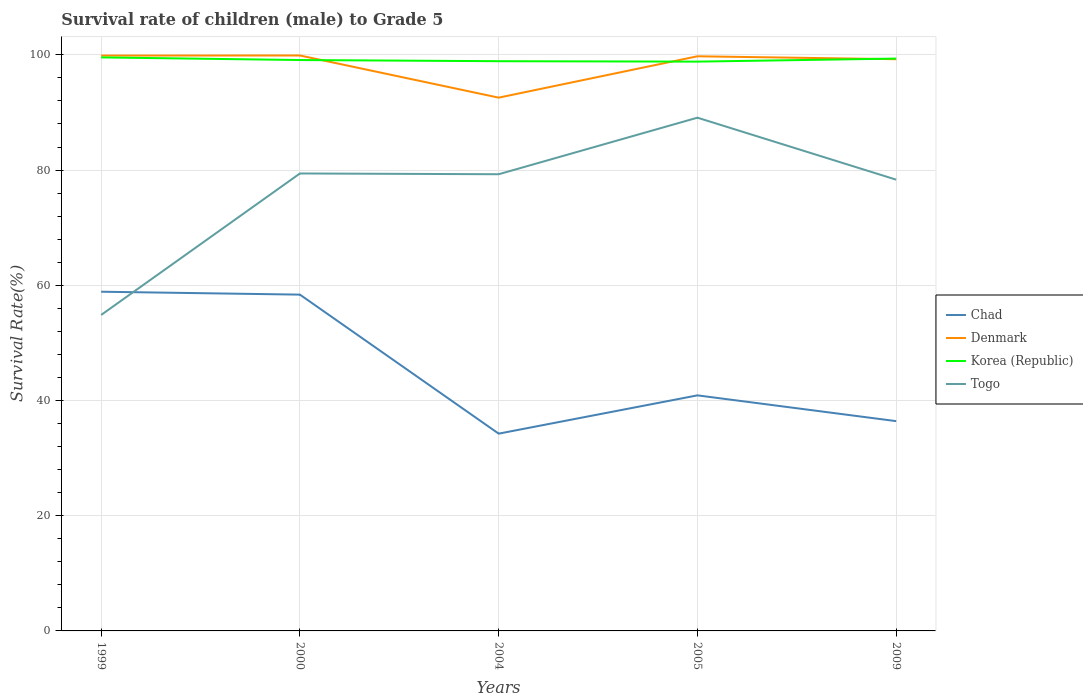Does the line corresponding to Chad intersect with the line corresponding to Korea (Republic)?
Ensure brevity in your answer.  No. Is the number of lines equal to the number of legend labels?
Provide a succinct answer. Yes. Across all years, what is the maximum survival rate of male children to grade 5 in Korea (Republic)?
Ensure brevity in your answer.  98.82. In which year was the survival rate of male children to grade 5 in Chad maximum?
Ensure brevity in your answer.  2004. What is the total survival rate of male children to grade 5 in Korea (Republic) in the graph?
Your answer should be very brief. -0.53. What is the difference between the highest and the second highest survival rate of male children to grade 5 in Togo?
Offer a very short reply. 34.24. How many lines are there?
Provide a succinct answer. 4. What is the difference between two consecutive major ticks on the Y-axis?
Keep it short and to the point. 20. Are the values on the major ticks of Y-axis written in scientific E-notation?
Provide a succinct answer. No. Does the graph contain grids?
Offer a terse response. Yes. Where does the legend appear in the graph?
Provide a succinct answer. Center right. How many legend labels are there?
Keep it short and to the point. 4. How are the legend labels stacked?
Your answer should be compact. Vertical. What is the title of the graph?
Offer a very short reply. Survival rate of children (male) to Grade 5. What is the label or title of the Y-axis?
Make the answer very short. Survival Rate(%). What is the Survival Rate(%) of Chad in 1999?
Offer a terse response. 58.88. What is the Survival Rate(%) in Denmark in 1999?
Ensure brevity in your answer.  99.88. What is the Survival Rate(%) of Korea (Republic) in 1999?
Provide a succinct answer. 99.56. What is the Survival Rate(%) of Togo in 1999?
Your answer should be compact. 54.85. What is the Survival Rate(%) in Chad in 2000?
Give a very brief answer. 58.38. What is the Survival Rate(%) in Denmark in 2000?
Your response must be concise. 99.89. What is the Survival Rate(%) of Korea (Republic) in 2000?
Your response must be concise. 99.1. What is the Survival Rate(%) in Togo in 2000?
Ensure brevity in your answer.  79.41. What is the Survival Rate(%) in Chad in 2004?
Provide a succinct answer. 34.25. What is the Survival Rate(%) of Denmark in 2004?
Ensure brevity in your answer.  92.57. What is the Survival Rate(%) in Korea (Republic) in 2004?
Your answer should be compact. 98.9. What is the Survival Rate(%) of Togo in 2004?
Provide a short and direct response. 79.28. What is the Survival Rate(%) in Chad in 2005?
Your answer should be compact. 40.89. What is the Survival Rate(%) in Denmark in 2005?
Ensure brevity in your answer.  99.75. What is the Survival Rate(%) in Korea (Republic) in 2005?
Ensure brevity in your answer.  98.82. What is the Survival Rate(%) in Togo in 2005?
Keep it short and to the point. 89.09. What is the Survival Rate(%) of Chad in 2009?
Ensure brevity in your answer.  36.42. What is the Survival Rate(%) in Denmark in 2009?
Give a very brief answer. 99.24. What is the Survival Rate(%) in Korea (Republic) in 2009?
Your answer should be very brief. 99.35. What is the Survival Rate(%) in Togo in 2009?
Make the answer very short. 78.33. Across all years, what is the maximum Survival Rate(%) of Chad?
Your answer should be very brief. 58.88. Across all years, what is the maximum Survival Rate(%) of Denmark?
Give a very brief answer. 99.89. Across all years, what is the maximum Survival Rate(%) in Korea (Republic)?
Offer a very short reply. 99.56. Across all years, what is the maximum Survival Rate(%) of Togo?
Ensure brevity in your answer.  89.09. Across all years, what is the minimum Survival Rate(%) of Chad?
Your response must be concise. 34.25. Across all years, what is the minimum Survival Rate(%) in Denmark?
Offer a very short reply. 92.57. Across all years, what is the minimum Survival Rate(%) of Korea (Republic)?
Give a very brief answer. 98.82. Across all years, what is the minimum Survival Rate(%) in Togo?
Your answer should be compact. 54.85. What is the total Survival Rate(%) in Chad in the graph?
Offer a terse response. 228.81. What is the total Survival Rate(%) in Denmark in the graph?
Your response must be concise. 491.33. What is the total Survival Rate(%) in Korea (Republic) in the graph?
Your response must be concise. 495.73. What is the total Survival Rate(%) in Togo in the graph?
Keep it short and to the point. 380.96. What is the difference between the Survival Rate(%) of Chad in 1999 and that in 2000?
Your response must be concise. 0.5. What is the difference between the Survival Rate(%) of Denmark in 1999 and that in 2000?
Ensure brevity in your answer.  -0.01. What is the difference between the Survival Rate(%) of Korea (Republic) in 1999 and that in 2000?
Make the answer very short. 0.46. What is the difference between the Survival Rate(%) of Togo in 1999 and that in 2000?
Your answer should be very brief. -24.56. What is the difference between the Survival Rate(%) in Chad in 1999 and that in 2004?
Make the answer very short. 24.63. What is the difference between the Survival Rate(%) in Denmark in 1999 and that in 2004?
Provide a short and direct response. 7.3. What is the difference between the Survival Rate(%) in Korea (Republic) in 1999 and that in 2004?
Offer a terse response. 0.66. What is the difference between the Survival Rate(%) in Togo in 1999 and that in 2004?
Ensure brevity in your answer.  -24.43. What is the difference between the Survival Rate(%) of Chad in 1999 and that in 2005?
Ensure brevity in your answer.  17.99. What is the difference between the Survival Rate(%) of Denmark in 1999 and that in 2005?
Give a very brief answer. 0.12. What is the difference between the Survival Rate(%) of Korea (Republic) in 1999 and that in 2005?
Provide a short and direct response. 0.73. What is the difference between the Survival Rate(%) of Togo in 1999 and that in 2005?
Offer a terse response. -34.24. What is the difference between the Survival Rate(%) in Chad in 1999 and that in 2009?
Keep it short and to the point. 22.46. What is the difference between the Survival Rate(%) of Denmark in 1999 and that in 2009?
Your answer should be very brief. 0.63. What is the difference between the Survival Rate(%) of Korea (Republic) in 1999 and that in 2009?
Offer a terse response. 0.21. What is the difference between the Survival Rate(%) of Togo in 1999 and that in 2009?
Your answer should be very brief. -23.48. What is the difference between the Survival Rate(%) in Chad in 2000 and that in 2004?
Your response must be concise. 24.13. What is the difference between the Survival Rate(%) in Denmark in 2000 and that in 2004?
Your answer should be compact. 7.32. What is the difference between the Survival Rate(%) in Korea (Republic) in 2000 and that in 2004?
Make the answer very short. 0.2. What is the difference between the Survival Rate(%) in Togo in 2000 and that in 2004?
Offer a very short reply. 0.13. What is the difference between the Survival Rate(%) of Chad in 2000 and that in 2005?
Provide a short and direct response. 17.49. What is the difference between the Survival Rate(%) of Denmark in 2000 and that in 2005?
Your answer should be compact. 0.14. What is the difference between the Survival Rate(%) in Korea (Republic) in 2000 and that in 2005?
Give a very brief answer. 0.28. What is the difference between the Survival Rate(%) in Togo in 2000 and that in 2005?
Give a very brief answer. -9.69. What is the difference between the Survival Rate(%) in Chad in 2000 and that in 2009?
Provide a succinct answer. 21.96. What is the difference between the Survival Rate(%) of Denmark in 2000 and that in 2009?
Ensure brevity in your answer.  0.65. What is the difference between the Survival Rate(%) in Korea (Republic) in 2000 and that in 2009?
Offer a very short reply. -0.25. What is the difference between the Survival Rate(%) of Togo in 2000 and that in 2009?
Make the answer very short. 1.07. What is the difference between the Survival Rate(%) in Chad in 2004 and that in 2005?
Provide a short and direct response. -6.65. What is the difference between the Survival Rate(%) in Denmark in 2004 and that in 2005?
Ensure brevity in your answer.  -7.18. What is the difference between the Survival Rate(%) in Korea (Republic) in 2004 and that in 2005?
Provide a short and direct response. 0.07. What is the difference between the Survival Rate(%) of Togo in 2004 and that in 2005?
Make the answer very short. -9.82. What is the difference between the Survival Rate(%) in Chad in 2004 and that in 2009?
Offer a terse response. -2.17. What is the difference between the Survival Rate(%) of Denmark in 2004 and that in 2009?
Offer a terse response. -6.67. What is the difference between the Survival Rate(%) in Korea (Republic) in 2004 and that in 2009?
Keep it short and to the point. -0.45. What is the difference between the Survival Rate(%) of Togo in 2004 and that in 2009?
Offer a terse response. 0.94. What is the difference between the Survival Rate(%) in Chad in 2005 and that in 2009?
Keep it short and to the point. 4.47. What is the difference between the Survival Rate(%) in Denmark in 2005 and that in 2009?
Make the answer very short. 0.51. What is the difference between the Survival Rate(%) of Korea (Republic) in 2005 and that in 2009?
Your response must be concise. -0.53. What is the difference between the Survival Rate(%) of Togo in 2005 and that in 2009?
Make the answer very short. 10.76. What is the difference between the Survival Rate(%) in Chad in 1999 and the Survival Rate(%) in Denmark in 2000?
Keep it short and to the point. -41.01. What is the difference between the Survival Rate(%) of Chad in 1999 and the Survival Rate(%) of Korea (Republic) in 2000?
Your answer should be very brief. -40.22. What is the difference between the Survival Rate(%) in Chad in 1999 and the Survival Rate(%) in Togo in 2000?
Your answer should be very brief. -20.53. What is the difference between the Survival Rate(%) in Denmark in 1999 and the Survival Rate(%) in Korea (Republic) in 2000?
Your answer should be very brief. 0.78. What is the difference between the Survival Rate(%) of Denmark in 1999 and the Survival Rate(%) of Togo in 2000?
Your response must be concise. 20.47. What is the difference between the Survival Rate(%) in Korea (Republic) in 1999 and the Survival Rate(%) in Togo in 2000?
Your response must be concise. 20.15. What is the difference between the Survival Rate(%) in Chad in 1999 and the Survival Rate(%) in Denmark in 2004?
Offer a very short reply. -33.69. What is the difference between the Survival Rate(%) in Chad in 1999 and the Survival Rate(%) in Korea (Republic) in 2004?
Offer a very short reply. -40.02. What is the difference between the Survival Rate(%) in Chad in 1999 and the Survival Rate(%) in Togo in 2004?
Make the answer very short. -20.39. What is the difference between the Survival Rate(%) of Denmark in 1999 and the Survival Rate(%) of Korea (Republic) in 2004?
Provide a succinct answer. 0.98. What is the difference between the Survival Rate(%) in Denmark in 1999 and the Survival Rate(%) in Togo in 2004?
Offer a very short reply. 20.6. What is the difference between the Survival Rate(%) of Korea (Republic) in 1999 and the Survival Rate(%) of Togo in 2004?
Your answer should be compact. 20.28. What is the difference between the Survival Rate(%) of Chad in 1999 and the Survival Rate(%) of Denmark in 2005?
Make the answer very short. -40.87. What is the difference between the Survival Rate(%) in Chad in 1999 and the Survival Rate(%) in Korea (Republic) in 2005?
Ensure brevity in your answer.  -39.94. What is the difference between the Survival Rate(%) in Chad in 1999 and the Survival Rate(%) in Togo in 2005?
Make the answer very short. -30.21. What is the difference between the Survival Rate(%) of Denmark in 1999 and the Survival Rate(%) of Korea (Republic) in 2005?
Your answer should be very brief. 1.05. What is the difference between the Survival Rate(%) of Denmark in 1999 and the Survival Rate(%) of Togo in 2005?
Your answer should be very brief. 10.78. What is the difference between the Survival Rate(%) of Korea (Republic) in 1999 and the Survival Rate(%) of Togo in 2005?
Make the answer very short. 10.46. What is the difference between the Survival Rate(%) of Chad in 1999 and the Survival Rate(%) of Denmark in 2009?
Provide a succinct answer. -40.36. What is the difference between the Survival Rate(%) of Chad in 1999 and the Survival Rate(%) of Korea (Republic) in 2009?
Provide a short and direct response. -40.47. What is the difference between the Survival Rate(%) of Chad in 1999 and the Survival Rate(%) of Togo in 2009?
Ensure brevity in your answer.  -19.45. What is the difference between the Survival Rate(%) of Denmark in 1999 and the Survival Rate(%) of Korea (Republic) in 2009?
Provide a succinct answer. 0.52. What is the difference between the Survival Rate(%) in Denmark in 1999 and the Survival Rate(%) in Togo in 2009?
Your response must be concise. 21.54. What is the difference between the Survival Rate(%) of Korea (Republic) in 1999 and the Survival Rate(%) of Togo in 2009?
Make the answer very short. 21.22. What is the difference between the Survival Rate(%) in Chad in 2000 and the Survival Rate(%) in Denmark in 2004?
Your answer should be compact. -34.19. What is the difference between the Survival Rate(%) of Chad in 2000 and the Survival Rate(%) of Korea (Republic) in 2004?
Your answer should be compact. -40.52. What is the difference between the Survival Rate(%) of Chad in 2000 and the Survival Rate(%) of Togo in 2004?
Offer a very short reply. -20.9. What is the difference between the Survival Rate(%) in Denmark in 2000 and the Survival Rate(%) in Togo in 2004?
Your response must be concise. 20.61. What is the difference between the Survival Rate(%) in Korea (Republic) in 2000 and the Survival Rate(%) in Togo in 2004?
Your answer should be compact. 19.83. What is the difference between the Survival Rate(%) in Chad in 2000 and the Survival Rate(%) in Denmark in 2005?
Keep it short and to the point. -41.37. What is the difference between the Survival Rate(%) of Chad in 2000 and the Survival Rate(%) of Korea (Republic) in 2005?
Give a very brief answer. -40.45. What is the difference between the Survival Rate(%) of Chad in 2000 and the Survival Rate(%) of Togo in 2005?
Your answer should be very brief. -30.72. What is the difference between the Survival Rate(%) of Denmark in 2000 and the Survival Rate(%) of Korea (Republic) in 2005?
Ensure brevity in your answer.  1.07. What is the difference between the Survival Rate(%) in Denmark in 2000 and the Survival Rate(%) in Togo in 2005?
Keep it short and to the point. 10.8. What is the difference between the Survival Rate(%) in Korea (Republic) in 2000 and the Survival Rate(%) in Togo in 2005?
Make the answer very short. 10.01. What is the difference between the Survival Rate(%) of Chad in 2000 and the Survival Rate(%) of Denmark in 2009?
Your answer should be compact. -40.87. What is the difference between the Survival Rate(%) in Chad in 2000 and the Survival Rate(%) in Korea (Republic) in 2009?
Keep it short and to the point. -40.97. What is the difference between the Survival Rate(%) in Chad in 2000 and the Survival Rate(%) in Togo in 2009?
Provide a succinct answer. -19.96. What is the difference between the Survival Rate(%) in Denmark in 2000 and the Survival Rate(%) in Korea (Republic) in 2009?
Keep it short and to the point. 0.54. What is the difference between the Survival Rate(%) in Denmark in 2000 and the Survival Rate(%) in Togo in 2009?
Ensure brevity in your answer.  21.56. What is the difference between the Survival Rate(%) in Korea (Republic) in 2000 and the Survival Rate(%) in Togo in 2009?
Provide a succinct answer. 20.77. What is the difference between the Survival Rate(%) of Chad in 2004 and the Survival Rate(%) of Denmark in 2005?
Give a very brief answer. -65.51. What is the difference between the Survival Rate(%) in Chad in 2004 and the Survival Rate(%) in Korea (Republic) in 2005?
Provide a short and direct response. -64.58. What is the difference between the Survival Rate(%) in Chad in 2004 and the Survival Rate(%) in Togo in 2005?
Your answer should be very brief. -54.85. What is the difference between the Survival Rate(%) of Denmark in 2004 and the Survival Rate(%) of Korea (Republic) in 2005?
Your answer should be very brief. -6.25. What is the difference between the Survival Rate(%) in Denmark in 2004 and the Survival Rate(%) in Togo in 2005?
Your answer should be very brief. 3.48. What is the difference between the Survival Rate(%) in Korea (Republic) in 2004 and the Survival Rate(%) in Togo in 2005?
Your response must be concise. 9.8. What is the difference between the Survival Rate(%) in Chad in 2004 and the Survival Rate(%) in Denmark in 2009?
Your answer should be very brief. -65. What is the difference between the Survival Rate(%) of Chad in 2004 and the Survival Rate(%) of Korea (Republic) in 2009?
Your answer should be very brief. -65.11. What is the difference between the Survival Rate(%) in Chad in 2004 and the Survival Rate(%) in Togo in 2009?
Keep it short and to the point. -44.09. What is the difference between the Survival Rate(%) in Denmark in 2004 and the Survival Rate(%) in Korea (Republic) in 2009?
Offer a very short reply. -6.78. What is the difference between the Survival Rate(%) in Denmark in 2004 and the Survival Rate(%) in Togo in 2009?
Offer a terse response. 14.24. What is the difference between the Survival Rate(%) in Korea (Republic) in 2004 and the Survival Rate(%) in Togo in 2009?
Make the answer very short. 20.56. What is the difference between the Survival Rate(%) of Chad in 2005 and the Survival Rate(%) of Denmark in 2009?
Provide a short and direct response. -58.35. What is the difference between the Survival Rate(%) of Chad in 2005 and the Survival Rate(%) of Korea (Republic) in 2009?
Offer a very short reply. -58.46. What is the difference between the Survival Rate(%) in Chad in 2005 and the Survival Rate(%) in Togo in 2009?
Offer a terse response. -37.44. What is the difference between the Survival Rate(%) of Denmark in 2005 and the Survival Rate(%) of Korea (Republic) in 2009?
Provide a short and direct response. 0.4. What is the difference between the Survival Rate(%) in Denmark in 2005 and the Survival Rate(%) in Togo in 2009?
Your answer should be very brief. 21.42. What is the difference between the Survival Rate(%) of Korea (Republic) in 2005 and the Survival Rate(%) of Togo in 2009?
Provide a short and direct response. 20.49. What is the average Survival Rate(%) in Chad per year?
Ensure brevity in your answer.  45.76. What is the average Survival Rate(%) of Denmark per year?
Give a very brief answer. 98.27. What is the average Survival Rate(%) of Korea (Republic) per year?
Provide a short and direct response. 99.15. What is the average Survival Rate(%) in Togo per year?
Your response must be concise. 76.19. In the year 1999, what is the difference between the Survival Rate(%) of Chad and Survival Rate(%) of Denmark?
Provide a short and direct response. -41. In the year 1999, what is the difference between the Survival Rate(%) of Chad and Survival Rate(%) of Korea (Republic)?
Your answer should be very brief. -40.68. In the year 1999, what is the difference between the Survival Rate(%) in Chad and Survival Rate(%) in Togo?
Give a very brief answer. 4.03. In the year 1999, what is the difference between the Survival Rate(%) in Denmark and Survival Rate(%) in Korea (Republic)?
Keep it short and to the point. 0.32. In the year 1999, what is the difference between the Survival Rate(%) in Denmark and Survival Rate(%) in Togo?
Ensure brevity in your answer.  45.03. In the year 1999, what is the difference between the Survival Rate(%) of Korea (Republic) and Survival Rate(%) of Togo?
Give a very brief answer. 44.71. In the year 2000, what is the difference between the Survival Rate(%) in Chad and Survival Rate(%) in Denmark?
Provide a succinct answer. -41.51. In the year 2000, what is the difference between the Survival Rate(%) in Chad and Survival Rate(%) in Korea (Republic)?
Keep it short and to the point. -40.72. In the year 2000, what is the difference between the Survival Rate(%) of Chad and Survival Rate(%) of Togo?
Your response must be concise. -21.03. In the year 2000, what is the difference between the Survival Rate(%) in Denmark and Survival Rate(%) in Korea (Republic)?
Keep it short and to the point. 0.79. In the year 2000, what is the difference between the Survival Rate(%) of Denmark and Survival Rate(%) of Togo?
Keep it short and to the point. 20.48. In the year 2000, what is the difference between the Survival Rate(%) in Korea (Republic) and Survival Rate(%) in Togo?
Provide a short and direct response. 19.69. In the year 2004, what is the difference between the Survival Rate(%) of Chad and Survival Rate(%) of Denmark?
Ensure brevity in your answer.  -58.33. In the year 2004, what is the difference between the Survival Rate(%) in Chad and Survival Rate(%) in Korea (Republic)?
Keep it short and to the point. -64.65. In the year 2004, what is the difference between the Survival Rate(%) in Chad and Survival Rate(%) in Togo?
Your answer should be very brief. -45.03. In the year 2004, what is the difference between the Survival Rate(%) of Denmark and Survival Rate(%) of Korea (Republic)?
Offer a very short reply. -6.33. In the year 2004, what is the difference between the Survival Rate(%) of Denmark and Survival Rate(%) of Togo?
Keep it short and to the point. 13.3. In the year 2004, what is the difference between the Survival Rate(%) in Korea (Republic) and Survival Rate(%) in Togo?
Provide a succinct answer. 19.62. In the year 2005, what is the difference between the Survival Rate(%) of Chad and Survival Rate(%) of Denmark?
Offer a very short reply. -58.86. In the year 2005, what is the difference between the Survival Rate(%) of Chad and Survival Rate(%) of Korea (Republic)?
Your answer should be compact. -57.93. In the year 2005, what is the difference between the Survival Rate(%) in Chad and Survival Rate(%) in Togo?
Provide a succinct answer. -48.2. In the year 2005, what is the difference between the Survival Rate(%) of Denmark and Survival Rate(%) of Korea (Republic)?
Your answer should be very brief. 0.93. In the year 2005, what is the difference between the Survival Rate(%) of Denmark and Survival Rate(%) of Togo?
Offer a very short reply. 10.66. In the year 2005, what is the difference between the Survival Rate(%) of Korea (Republic) and Survival Rate(%) of Togo?
Offer a very short reply. 9.73. In the year 2009, what is the difference between the Survival Rate(%) in Chad and Survival Rate(%) in Denmark?
Give a very brief answer. -62.83. In the year 2009, what is the difference between the Survival Rate(%) in Chad and Survival Rate(%) in Korea (Republic)?
Your answer should be compact. -62.93. In the year 2009, what is the difference between the Survival Rate(%) of Chad and Survival Rate(%) of Togo?
Make the answer very short. -41.92. In the year 2009, what is the difference between the Survival Rate(%) of Denmark and Survival Rate(%) of Korea (Republic)?
Ensure brevity in your answer.  -0.11. In the year 2009, what is the difference between the Survival Rate(%) in Denmark and Survival Rate(%) in Togo?
Provide a short and direct response. 20.91. In the year 2009, what is the difference between the Survival Rate(%) of Korea (Republic) and Survival Rate(%) of Togo?
Make the answer very short. 21.02. What is the ratio of the Survival Rate(%) in Chad in 1999 to that in 2000?
Provide a succinct answer. 1.01. What is the ratio of the Survival Rate(%) of Denmark in 1999 to that in 2000?
Offer a terse response. 1. What is the ratio of the Survival Rate(%) in Korea (Republic) in 1999 to that in 2000?
Ensure brevity in your answer.  1. What is the ratio of the Survival Rate(%) of Togo in 1999 to that in 2000?
Offer a terse response. 0.69. What is the ratio of the Survival Rate(%) in Chad in 1999 to that in 2004?
Offer a terse response. 1.72. What is the ratio of the Survival Rate(%) in Denmark in 1999 to that in 2004?
Make the answer very short. 1.08. What is the ratio of the Survival Rate(%) of Togo in 1999 to that in 2004?
Ensure brevity in your answer.  0.69. What is the ratio of the Survival Rate(%) in Chad in 1999 to that in 2005?
Give a very brief answer. 1.44. What is the ratio of the Survival Rate(%) of Denmark in 1999 to that in 2005?
Offer a terse response. 1. What is the ratio of the Survival Rate(%) of Korea (Republic) in 1999 to that in 2005?
Offer a very short reply. 1.01. What is the ratio of the Survival Rate(%) of Togo in 1999 to that in 2005?
Make the answer very short. 0.62. What is the ratio of the Survival Rate(%) of Chad in 1999 to that in 2009?
Your answer should be very brief. 1.62. What is the ratio of the Survival Rate(%) in Denmark in 1999 to that in 2009?
Your answer should be compact. 1.01. What is the ratio of the Survival Rate(%) in Togo in 1999 to that in 2009?
Keep it short and to the point. 0.7. What is the ratio of the Survival Rate(%) of Chad in 2000 to that in 2004?
Ensure brevity in your answer.  1.7. What is the ratio of the Survival Rate(%) in Denmark in 2000 to that in 2004?
Your answer should be very brief. 1.08. What is the ratio of the Survival Rate(%) in Korea (Republic) in 2000 to that in 2004?
Ensure brevity in your answer.  1. What is the ratio of the Survival Rate(%) of Togo in 2000 to that in 2004?
Offer a terse response. 1. What is the ratio of the Survival Rate(%) in Chad in 2000 to that in 2005?
Provide a short and direct response. 1.43. What is the ratio of the Survival Rate(%) in Korea (Republic) in 2000 to that in 2005?
Give a very brief answer. 1. What is the ratio of the Survival Rate(%) of Togo in 2000 to that in 2005?
Give a very brief answer. 0.89. What is the ratio of the Survival Rate(%) in Chad in 2000 to that in 2009?
Your answer should be very brief. 1.6. What is the ratio of the Survival Rate(%) in Denmark in 2000 to that in 2009?
Your response must be concise. 1.01. What is the ratio of the Survival Rate(%) of Togo in 2000 to that in 2009?
Keep it short and to the point. 1.01. What is the ratio of the Survival Rate(%) in Chad in 2004 to that in 2005?
Your answer should be compact. 0.84. What is the ratio of the Survival Rate(%) of Denmark in 2004 to that in 2005?
Offer a very short reply. 0.93. What is the ratio of the Survival Rate(%) in Togo in 2004 to that in 2005?
Make the answer very short. 0.89. What is the ratio of the Survival Rate(%) in Chad in 2004 to that in 2009?
Provide a short and direct response. 0.94. What is the ratio of the Survival Rate(%) in Denmark in 2004 to that in 2009?
Your answer should be compact. 0.93. What is the ratio of the Survival Rate(%) in Korea (Republic) in 2004 to that in 2009?
Ensure brevity in your answer.  1. What is the ratio of the Survival Rate(%) in Chad in 2005 to that in 2009?
Ensure brevity in your answer.  1.12. What is the ratio of the Survival Rate(%) in Denmark in 2005 to that in 2009?
Keep it short and to the point. 1.01. What is the ratio of the Survival Rate(%) of Togo in 2005 to that in 2009?
Give a very brief answer. 1.14. What is the difference between the highest and the second highest Survival Rate(%) of Chad?
Keep it short and to the point. 0.5. What is the difference between the highest and the second highest Survival Rate(%) of Denmark?
Provide a short and direct response. 0.01. What is the difference between the highest and the second highest Survival Rate(%) in Korea (Republic)?
Your answer should be compact. 0.21. What is the difference between the highest and the second highest Survival Rate(%) of Togo?
Give a very brief answer. 9.69. What is the difference between the highest and the lowest Survival Rate(%) in Chad?
Provide a succinct answer. 24.63. What is the difference between the highest and the lowest Survival Rate(%) of Denmark?
Give a very brief answer. 7.32. What is the difference between the highest and the lowest Survival Rate(%) of Korea (Republic)?
Offer a very short reply. 0.73. What is the difference between the highest and the lowest Survival Rate(%) of Togo?
Provide a short and direct response. 34.24. 